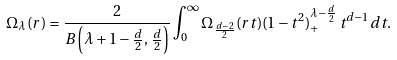Convert formula to latex. <formula><loc_0><loc_0><loc_500><loc_500>\Omega _ { \lambda } ( r ) = \frac { 2 } { B \left ( \lambda + 1 - \frac { d } { 2 } , \, \frac { d } { 2 } \right ) } \int _ { 0 } ^ { \infty } \Omega _ { \frac { d - 2 } { 2 } } ( r t ) ( 1 - t ^ { 2 } ) _ { + } ^ { \lambda - \frac { d } { 2 } } \, t ^ { d - 1 } d t .</formula> 